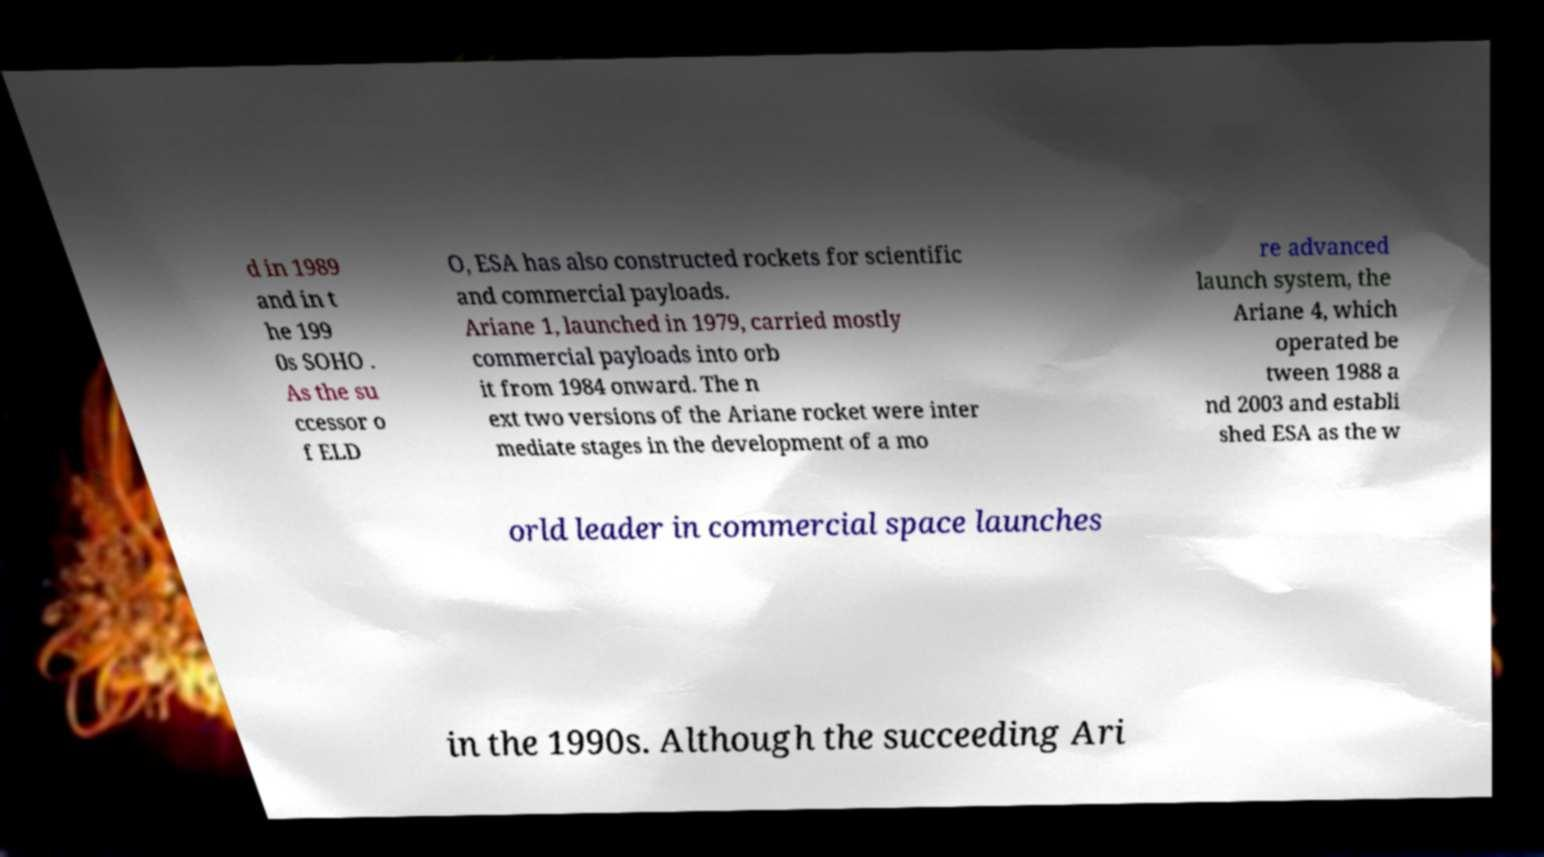Can you read and provide the text displayed in the image?This photo seems to have some interesting text. Can you extract and type it out for me? d in 1989 and in t he 199 0s SOHO . As the su ccessor o f ELD O, ESA has also constructed rockets for scientific and commercial payloads. Ariane 1, launched in 1979, carried mostly commercial payloads into orb it from 1984 onward. The n ext two versions of the Ariane rocket were inter mediate stages in the development of a mo re advanced launch system, the Ariane 4, which operated be tween 1988 a nd 2003 and establi shed ESA as the w orld leader in commercial space launches in the 1990s. Although the succeeding Ari 